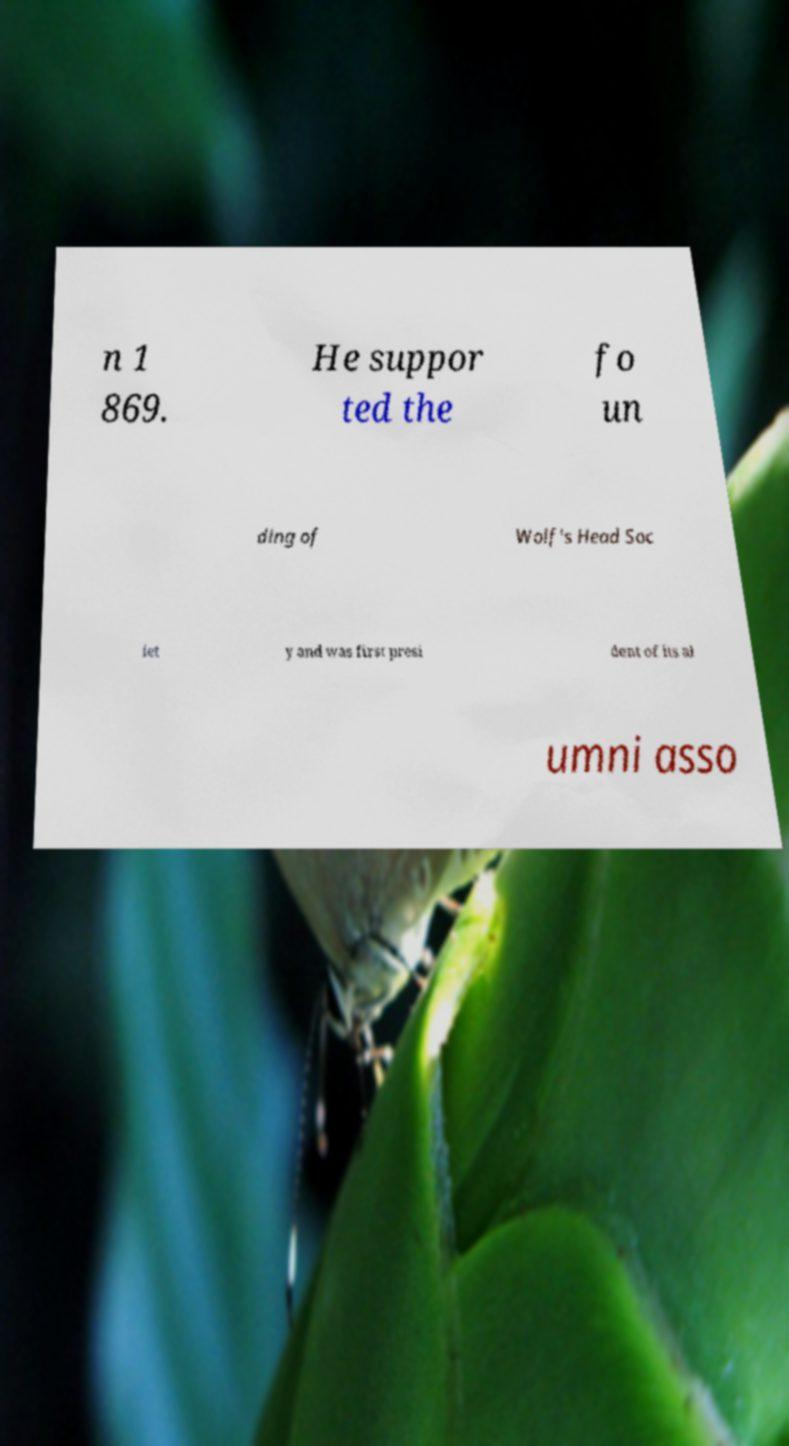Can you accurately transcribe the text from the provided image for me? n 1 869. He suppor ted the fo un ding of Wolf's Head Soc iet y and was first presi dent of its al umni asso 